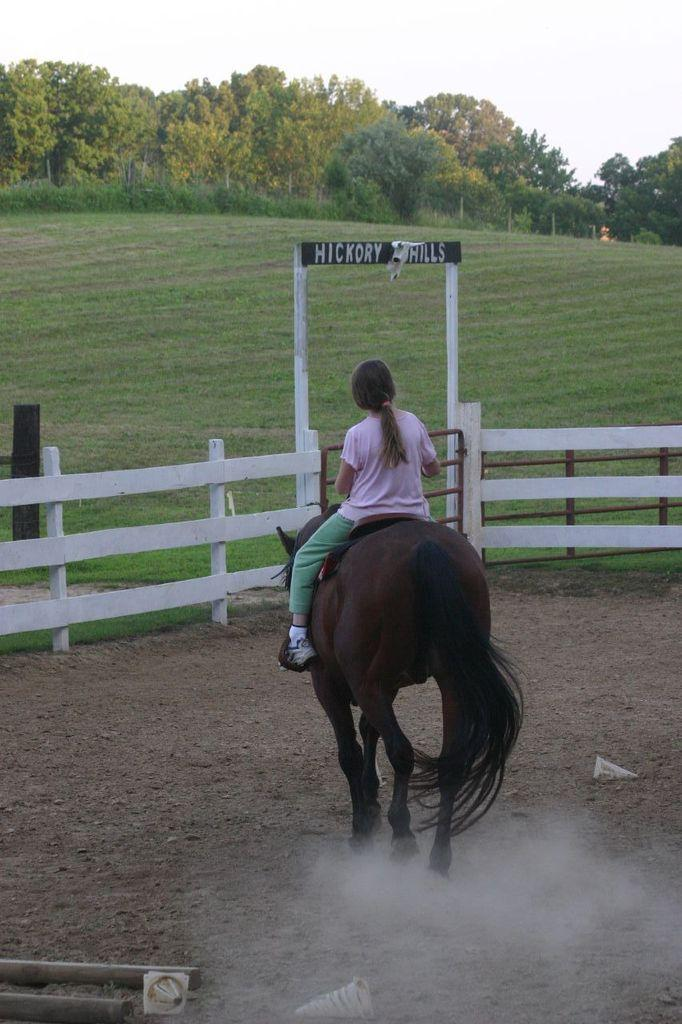Who is the main subject in the image? There is a girl in the image. What is the girl doing in the image? The girl is sitting on a horse. What can be seen in front of the girl? There is a wooden railing in front of the girl. What type of natural environment is visible in the image? Trees are present in the image. What is the topic of the argument taking place between the girl and the horse in the image? There is no argument present in the image; the girl is simply sitting on the horse. 